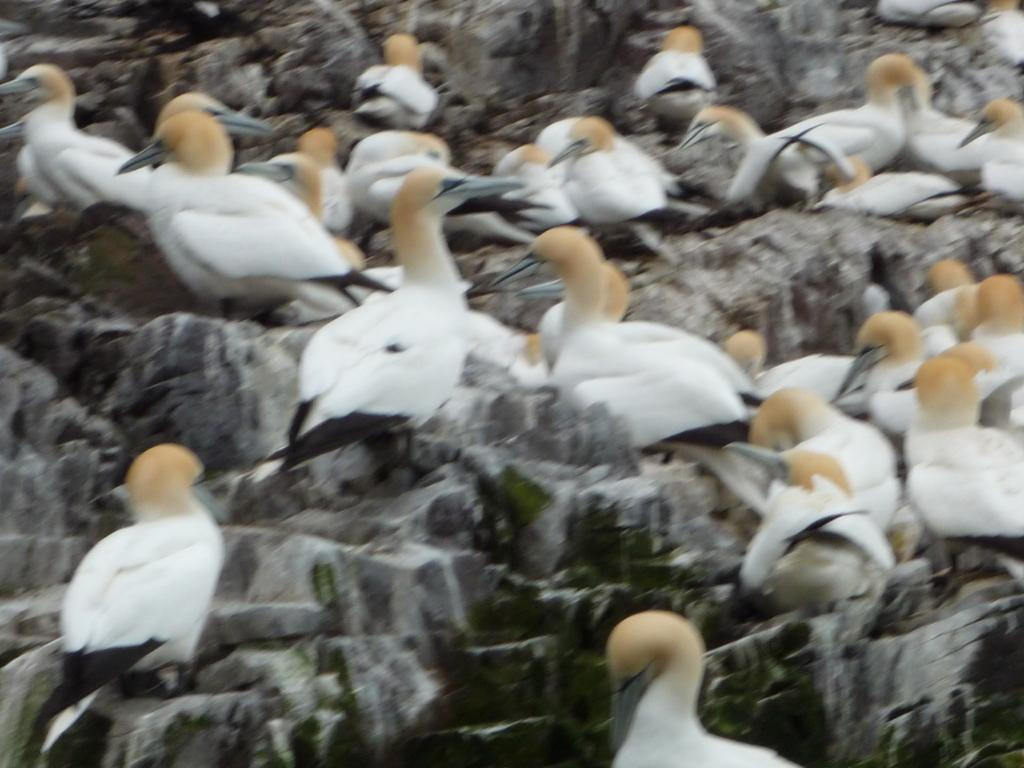What is the quality of the image? The picture is blurry. What type of animals can be seen in the image? Birds are visible in the image. Where is the cushion located in the image? There is no cushion present in the image. What type of sporting equipment can be seen in the image? There is no sporting equipment, such as a basketball, present in the image. 